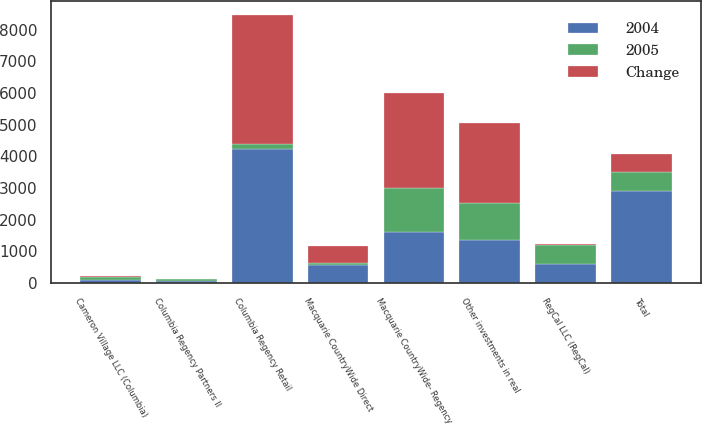Convert chart to OTSL. <chart><loc_0><loc_0><loc_500><loc_500><stacked_bar_chart><ecel><fcel>Macquarie CountryWide- Regency<fcel>Macquarie CountryWide Direct<fcel>Columbia Regency Retail<fcel>Cameron Village LLC (Columbia)<fcel>Columbia Regency Partners II<fcel>RegCal LLC (RegCal)<fcel>Other investments in real<fcel>Total<nl><fcel>2004<fcel>1601<fcel>578<fcel>4241<fcel>98<fcel>63<fcel>609<fcel>1373<fcel>2908<nl><fcel>Change<fcel>2997<fcel>535<fcel>4103<fcel>8<fcel>1<fcel>18<fcel>2532<fcel>584.5<nl><fcel>2005<fcel>1396<fcel>43<fcel>138<fcel>106<fcel>62<fcel>591<fcel>1159<fcel>584.5<nl></chart> 